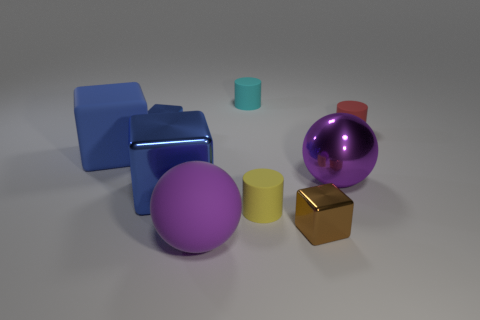How many blue blocks must be subtracted to get 1 blue blocks? 2 Subtract all cyan cylinders. How many blue blocks are left? 3 Add 1 tiny metallic cubes. How many objects exist? 10 Subtract all cylinders. How many objects are left? 6 Add 6 tiny cyan objects. How many tiny cyan objects exist? 7 Subtract 0 gray cubes. How many objects are left? 9 Subtract all small brown blocks. Subtract all large blue objects. How many objects are left? 6 Add 7 small metallic blocks. How many small metallic blocks are left? 9 